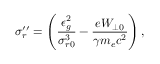<formula> <loc_0><loc_0><loc_500><loc_500>\sigma _ { r } ^ { \prime \prime } = \left ( \frac { \epsilon _ { g } ^ { 2 } } { \sigma _ { r 0 } ^ { 3 } } - \frac { e W _ { \perp 0 } } { \gamma m _ { e } c ^ { 2 } } \right ) ,</formula> 